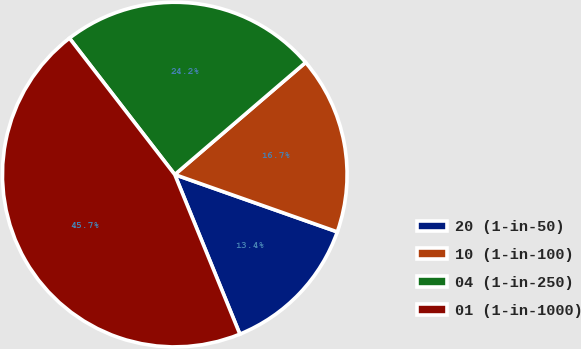<chart> <loc_0><loc_0><loc_500><loc_500><pie_chart><fcel>20 (1-in-50)<fcel>10 (1-in-100)<fcel>04 (1-in-250)<fcel>01 (1-in-1000)<nl><fcel>13.44%<fcel>16.67%<fcel>24.19%<fcel>45.7%<nl></chart> 